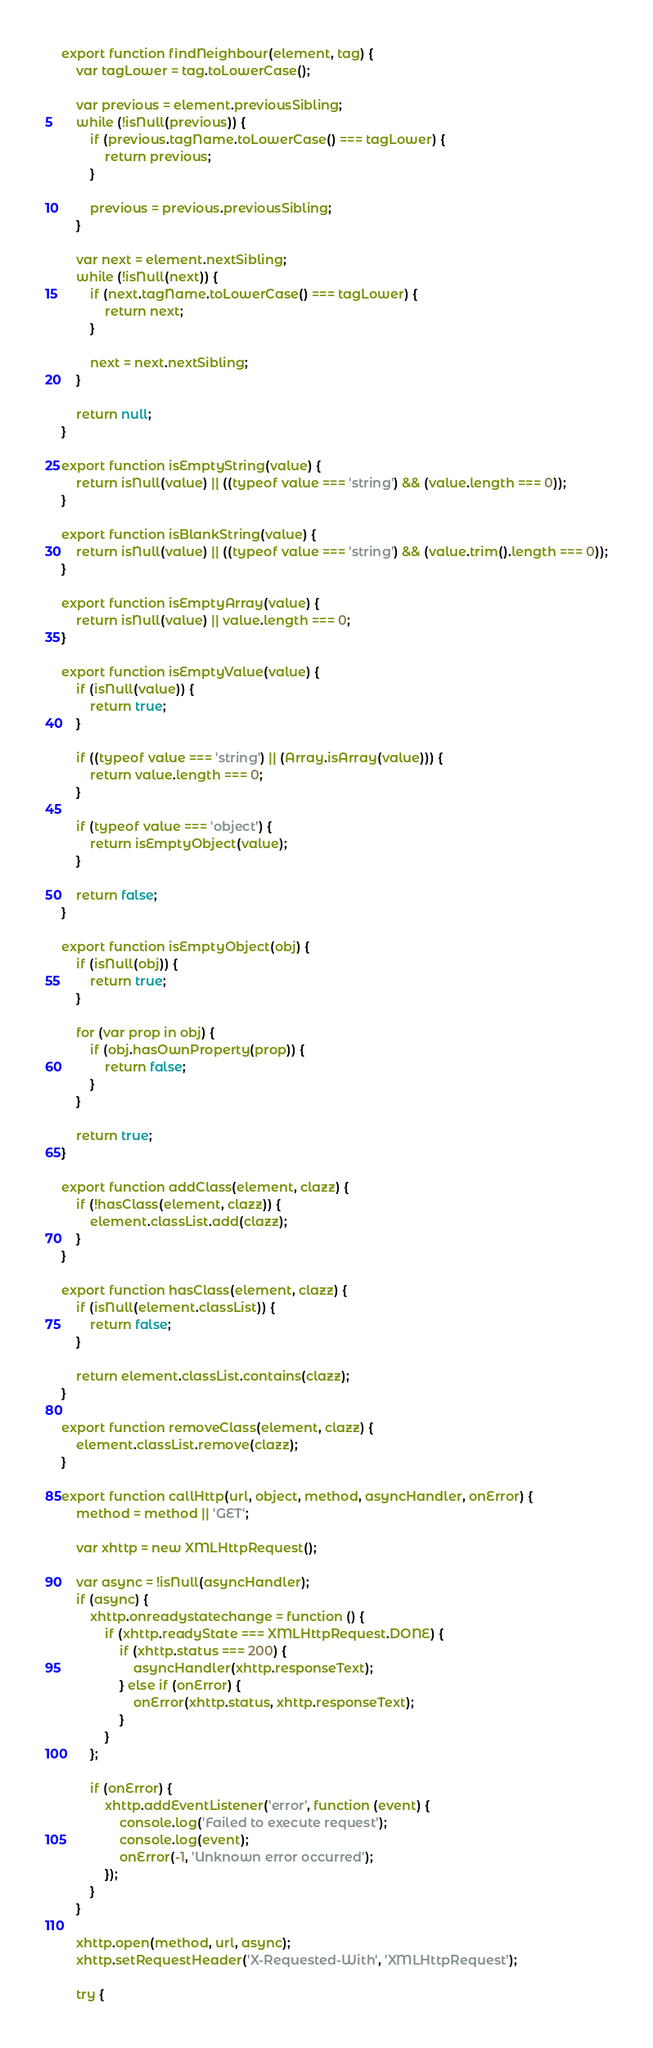<code> <loc_0><loc_0><loc_500><loc_500><_JavaScript_>export function findNeighbour(element, tag) {
    var tagLower = tag.toLowerCase();

    var previous = element.previousSibling;
    while (!isNull(previous)) {
        if (previous.tagName.toLowerCase() === tagLower) {
            return previous;
        }

        previous = previous.previousSibling;
    }

    var next = element.nextSibling;
    while (!isNull(next)) {
        if (next.tagName.toLowerCase() === tagLower) {
            return next;
        }

        next = next.nextSibling;
    }

    return null;
}

export function isEmptyString(value) {
    return isNull(value) || ((typeof value === 'string') && (value.length === 0));
}

export function isBlankString(value) {
    return isNull(value) || ((typeof value === 'string') && (value.trim().length === 0));
}

export function isEmptyArray(value) {
    return isNull(value) || value.length === 0;
}

export function isEmptyValue(value) {
    if (isNull(value)) {
        return true;
    }

    if ((typeof value === 'string') || (Array.isArray(value))) {
        return value.length === 0;
    }

    if (typeof value === 'object') {
        return isEmptyObject(value);
    }

    return false;
}

export function isEmptyObject(obj) {
    if (isNull(obj)) {
        return true;
    }

    for (var prop in obj) {
        if (obj.hasOwnProperty(prop)) {
            return false;
        }
    }

    return true;
}

export function addClass(element, clazz) {
    if (!hasClass(element, clazz)) {
        element.classList.add(clazz);
    }
}

export function hasClass(element, clazz) {
    if (isNull(element.classList)) {
        return false;
    }

    return element.classList.contains(clazz);
}

export function removeClass(element, clazz) {
    element.classList.remove(clazz);
}

export function callHttp(url, object, method, asyncHandler, onError) {
    method = method || 'GET';

    var xhttp = new XMLHttpRequest();

    var async = !isNull(asyncHandler);
    if (async) {
        xhttp.onreadystatechange = function () {
            if (xhttp.readyState === XMLHttpRequest.DONE) {
                if (xhttp.status === 200) {
                    asyncHandler(xhttp.responseText);
                } else if (onError) {
                    onError(xhttp.status, xhttp.responseText);
                }
            }
        };

        if (onError) {
            xhttp.addEventListener('error', function (event) {
                console.log('Failed to execute request');
                console.log(event);
                onError(-1, 'Unknown error occurred');
            });
        }
    }

    xhttp.open(method, url, async);
    xhttp.setRequestHeader('X-Requested-With', 'XMLHttpRequest');

    try {</code> 